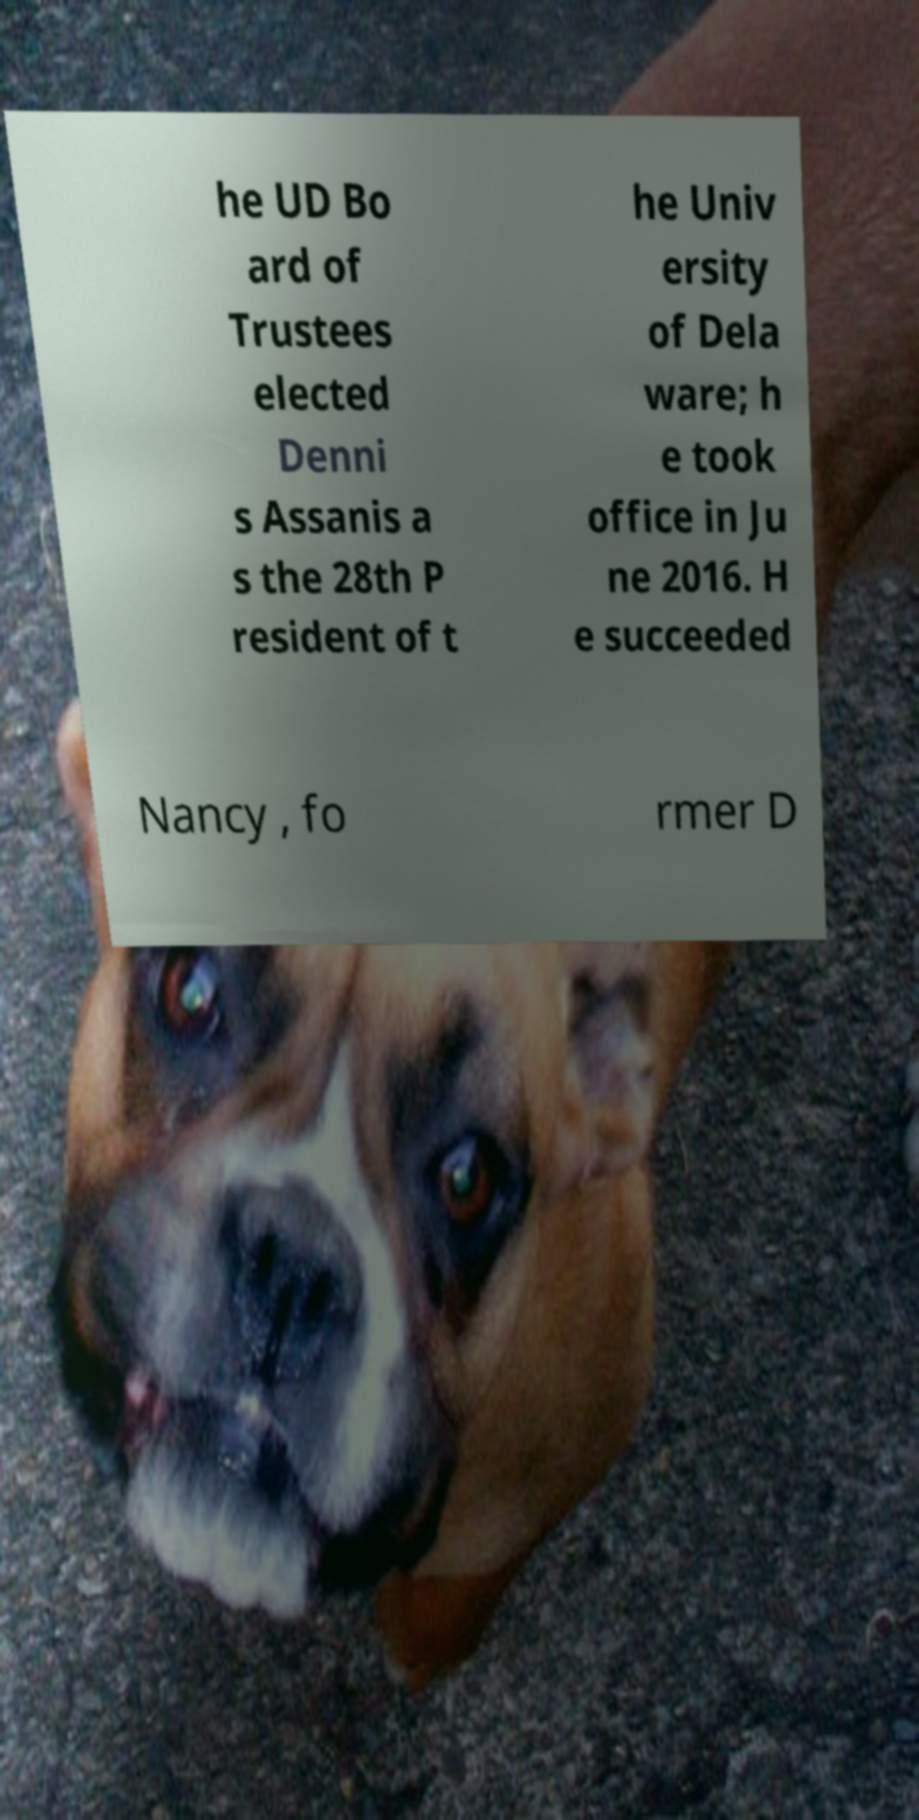What messages or text are displayed in this image? I need them in a readable, typed format. he UD Bo ard of Trustees elected Denni s Assanis a s the 28th P resident of t he Univ ersity of Dela ware; h e took office in Ju ne 2016. H e succeeded Nancy , fo rmer D 